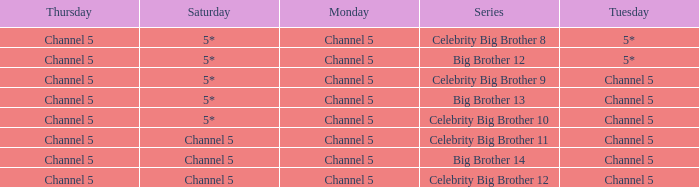Which series airs Saturday on Channel 5? Celebrity Big Brother 11, Big Brother 14, Celebrity Big Brother 12. 